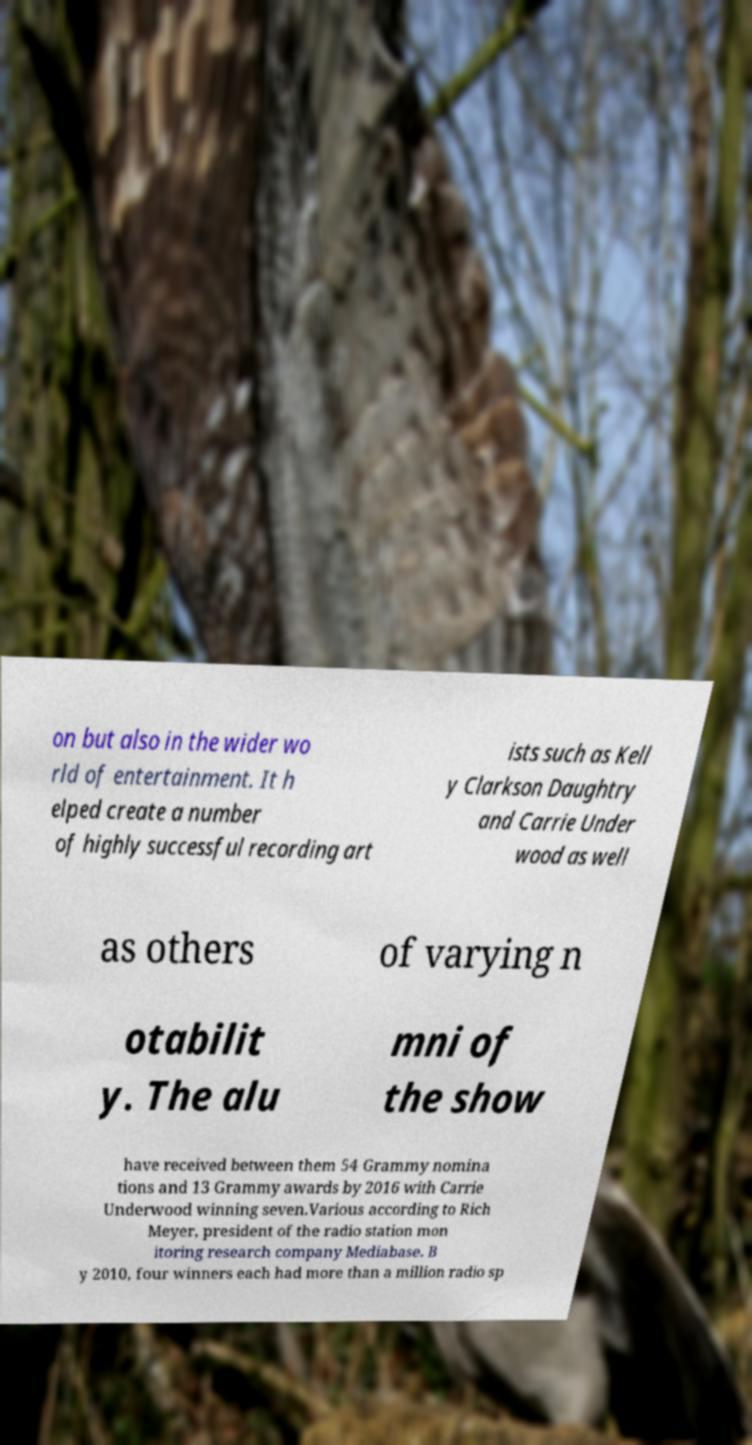What messages or text are displayed in this image? I need them in a readable, typed format. on but also in the wider wo rld of entertainment. It h elped create a number of highly successful recording art ists such as Kell y Clarkson Daughtry and Carrie Under wood as well as others of varying n otabilit y. The alu mni of the show have received between them 54 Grammy nomina tions and 13 Grammy awards by 2016 with Carrie Underwood winning seven.Various according to Rich Meyer, president of the radio station mon itoring research company Mediabase. B y 2010, four winners each had more than a million radio sp 